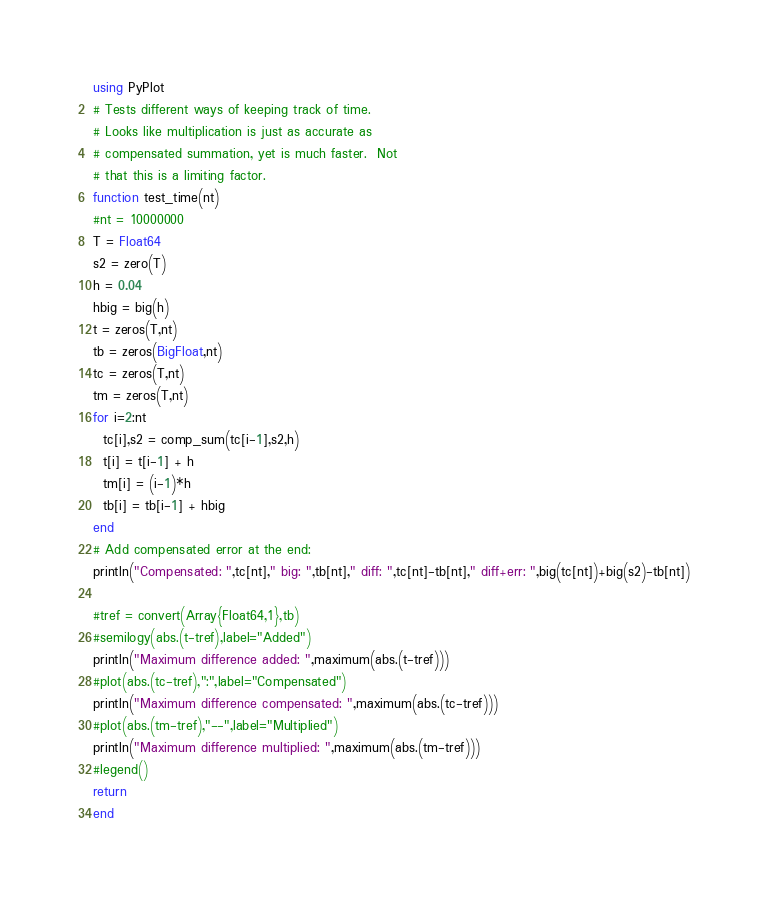Convert code to text. <code><loc_0><loc_0><loc_500><loc_500><_Julia_>
using PyPlot
# Tests different ways of keeping track of time.
# Looks like multiplication is just as accurate as
# compensated summation, yet is much faster.  Not
# that this is a limiting factor.
function test_time(nt)
#nt = 10000000
T = Float64
s2 = zero(T)
h = 0.04
hbig = big(h)
t = zeros(T,nt)
tb = zeros(BigFloat,nt)
tc = zeros(T,nt)
tm = zeros(T,nt)
for i=2:nt
  tc[i],s2 = comp_sum(tc[i-1],s2,h)
  t[i] = t[i-1] + h
  tm[i] = (i-1)*h
  tb[i] = tb[i-1] + hbig
end
# Add compensated error at the end:
println("Compensated: ",tc[nt]," big: ",tb[nt]," diff: ",tc[nt]-tb[nt]," diff+err: ",big(tc[nt])+big(s2)-tb[nt])

#tref = convert(Array{Float64,1},tb)
#semilogy(abs.(t-tref),label="Added")
println("Maximum difference added: ",maximum(abs.(t-tref)))
#plot(abs.(tc-tref),":",label="Compensated")
println("Maximum difference compensated: ",maximum(abs.(tc-tref)))
#plot(abs.(tm-tref),"--",label="Multiplied")
println("Maximum difference multiplied: ",maximum(abs.(tm-tref)))
#legend()
return
end
</code> 